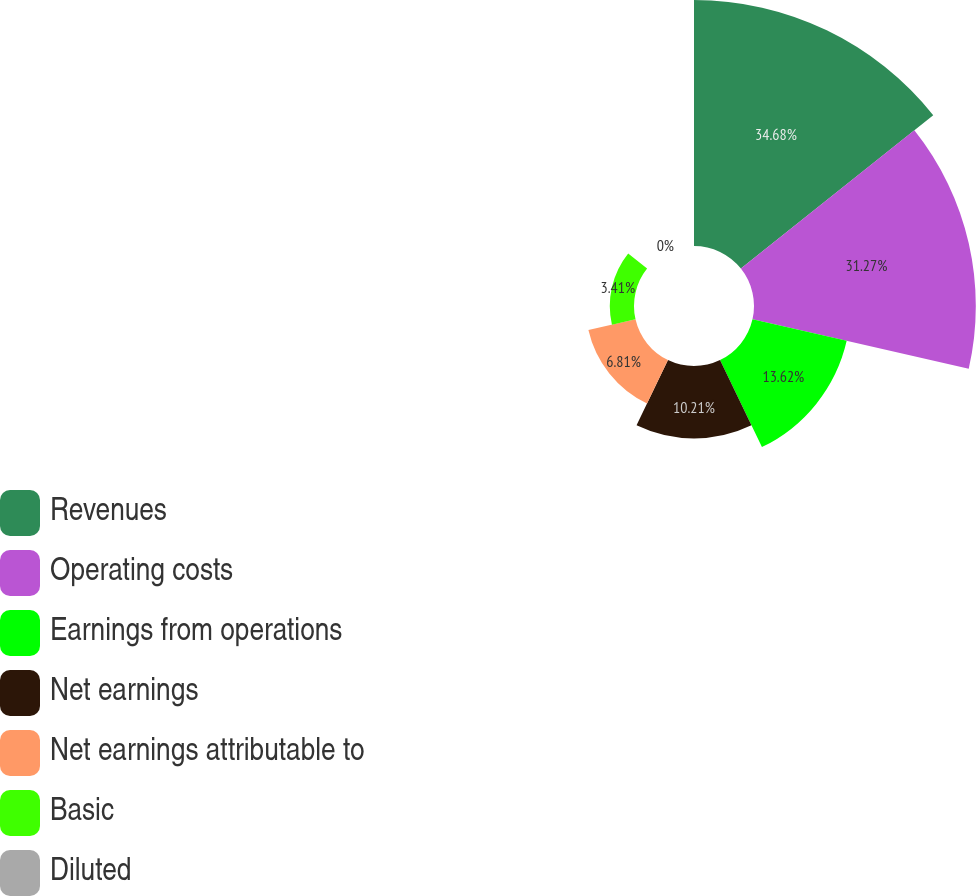Convert chart to OTSL. <chart><loc_0><loc_0><loc_500><loc_500><pie_chart><fcel>Revenues<fcel>Operating costs<fcel>Earnings from operations<fcel>Net earnings<fcel>Net earnings attributable to<fcel>Basic<fcel>Diluted<nl><fcel>34.68%<fcel>31.27%<fcel>13.62%<fcel>10.21%<fcel>6.81%<fcel>3.41%<fcel>0.0%<nl></chart> 